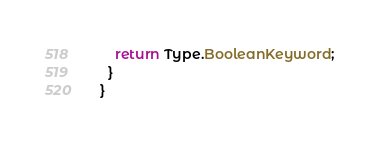<code> <loc_0><loc_0><loc_500><loc_500><_Java_>    return Type.BooleanKeyword;
  }
}
</code> 